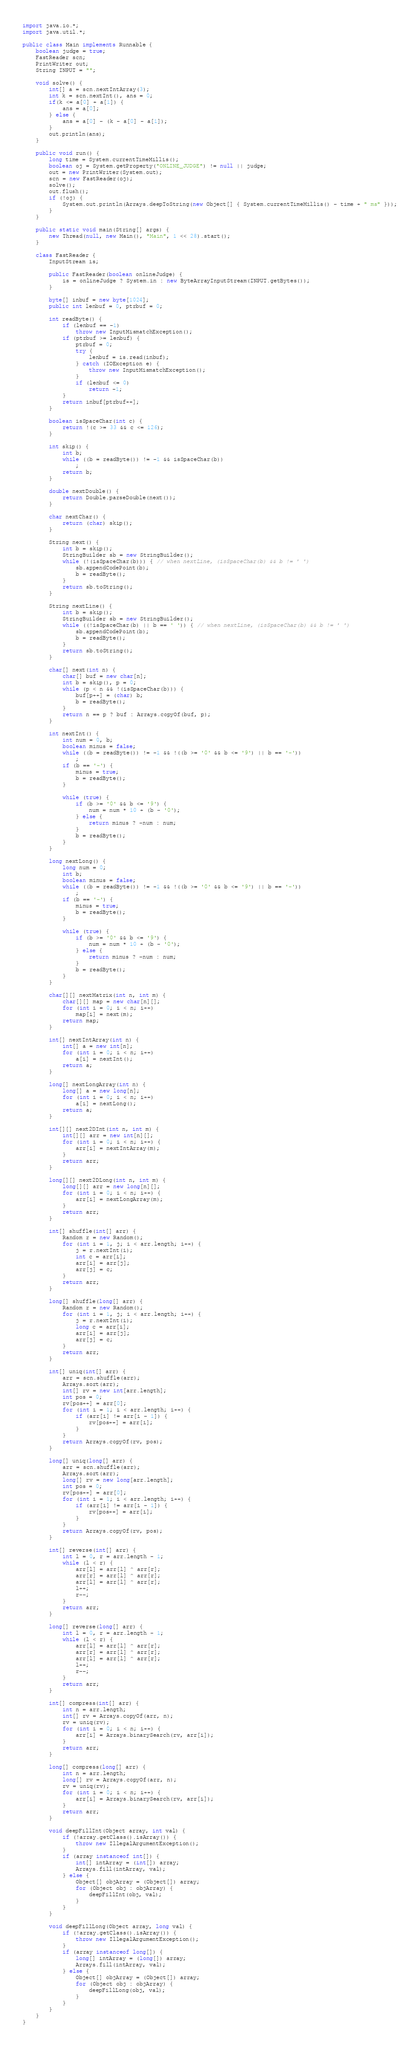<code> <loc_0><loc_0><loc_500><loc_500><_Java_>import java.io.*;
import java.util.*;

public class Main implements Runnable {
	boolean judge = true;
	FastReader scn;
	PrintWriter out;
	String INPUT = "";

	void solve() {
		int[] a = scn.nextIntArray(3);
		int k = scn.nextInt(), ans = 0;
		if(k <= a[0] + a[1]) {
			ans = a[0];
		} else {
			ans = a[0] - (k - a[0] - a[1]);
		}
		out.println(ans);
	}

	public void run() {
		long time = System.currentTimeMillis();
		boolean oj = System.getProperty("ONLINE_JUDGE") != null || judge;
		out = new PrintWriter(System.out);
		scn = new FastReader(oj);
		solve();
		out.flush();
		if (!oj) {
			System.out.println(Arrays.deepToString(new Object[] { System.currentTimeMillis() - time + " ms" }));
		}
	}

	public static void main(String[] args) {
		new Thread(null, new Main(), "Main", 1 << 28).start();
	}

	class FastReader {
		InputStream is;

		public FastReader(boolean onlineJudge) {
			is = onlineJudge ? System.in : new ByteArrayInputStream(INPUT.getBytes());
		}

		byte[] inbuf = new byte[1024];
		public int lenbuf = 0, ptrbuf = 0;

		int readByte() {
			if (lenbuf == -1)
				throw new InputMismatchException();
			if (ptrbuf >= lenbuf) {
				ptrbuf = 0;
				try {
					lenbuf = is.read(inbuf);
				} catch (IOException e) {
					throw new InputMismatchException();
				}
				if (lenbuf <= 0)
					return -1;
			}
			return inbuf[ptrbuf++];
		}

		boolean isSpaceChar(int c) {
			return !(c >= 33 && c <= 126);
		}

		int skip() {
			int b;
			while ((b = readByte()) != -1 && isSpaceChar(b))
				;
			return b;
		}

		double nextDouble() {
			return Double.parseDouble(next());
		}

		char nextChar() {
			return (char) skip();
		}

		String next() {
			int b = skip();
			StringBuilder sb = new StringBuilder();
			while (!(isSpaceChar(b))) { // when nextLine, (isSpaceChar(b) && b != ' ')
				sb.appendCodePoint(b);
				b = readByte();
			}
			return sb.toString();
		}

		String nextLine() {
			int b = skip();
			StringBuilder sb = new StringBuilder();
			while ((!isSpaceChar(b) || b == ' ')) { // when nextLine, (isSpaceChar(b) && b != ' ')
				sb.appendCodePoint(b);
				b = readByte();
			}
			return sb.toString();
		}

		char[] next(int n) {
			char[] buf = new char[n];
			int b = skip(), p = 0;
			while (p < n && !(isSpaceChar(b))) {
				buf[p++] = (char) b;
				b = readByte();
			}
			return n == p ? buf : Arrays.copyOf(buf, p);
		}

		int nextInt() {
			int num = 0, b;
			boolean minus = false;
			while ((b = readByte()) != -1 && !((b >= '0' && b <= '9') || b == '-'))
				;
			if (b == '-') {
				minus = true;
				b = readByte();
			}

			while (true) {
				if (b >= '0' && b <= '9') {
					num = num * 10 + (b - '0');
				} else {
					return minus ? -num : num;
				}
				b = readByte();
			}
		}

		long nextLong() {
			long num = 0;
			int b;
			boolean minus = false;
			while ((b = readByte()) != -1 && !((b >= '0' && b <= '9') || b == '-'))
				;
			if (b == '-') {
				minus = true;
				b = readByte();
			}

			while (true) {
				if (b >= '0' && b <= '9') {
					num = num * 10 + (b - '0');
				} else {
					return minus ? -num : num;
				}
				b = readByte();
			}
		}

		char[][] nextMatrix(int n, int m) {
			char[][] map = new char[n][];
			for (int i = 0; i < n; i++)
				map[i] = next(m);
			return map;
		}

		int[] nextIntArray(int n) {
			int[] a = new int[n];
			for (int i = 0; i < n; i++)
				a[i] = nextInt();
			return a;
		}

		long[] nextLongArray(int n) {
			long[] a = new long[n];
			for (int i = 0; i < n; i++)
				a[i] = nextLong();
			return a;
		}

		int[][] next2DInt(int n, int m) {
			int[][] arr = new int[n][];
			for (int i = 0; i < n; i++) {
				arr[i] = nextIntArray(m);
			}
			return arr;
		}

		long[][] next2DLong(int n, int m) {
			long[][] arr = new long[n][];
			for (int i = 0; i < n; i++) {
				arr[i] = nextLongArray(m);
			}
			return arr;
		}

		int[] shuffle(int[] arr) {
			Random r = new Random();
			for (int i = 1, j; i < arr.length; i++) {
				j = r.nextInt(i);
				int c = arr[i];
				arr[i] = arr[j];
				arr[j] = c;
			}
			return arr;
		}

		long[] shuffle(long[] arr) {
			Random r = new Random();
			for (int i = 1, j; i < arr.length; i++) {
				j = r.nextInt(i);
				long c = arr[i];
				arr[i] = arr[j];
				arr[j] = c;
			}
			return arr;
		}

		int[] uniq(int[] arr) {
			arr = scn.shuffle(arr);
			Arrays.sort(arr);
			int[] rv = new int[arr.length];
			int pos = 0;
			rv[pos++] = arr[0];
			for (int i = 1; i < arr.length; i++) {
				if (arr[i] != arr[i - 1]) {
					rv[pos++] = arr[i];
				}
			}
			return Arrays.copyOf(rv, pos);
		}

		long[] uniq(long[] arr) {
			arr = scn.shuffle(arr);
			Arrays.sort(arr);
			long[] rv = new long[arr.length];
			int pos = 0;
			rv[pos++] = arr[0];
			for (int i = 1; i < arr.length; i++) {
				if (arr[i] != arr[i - 1]) {
					rv[pos++] = arr[i];
				}
			}
			return Arrays.copyOf(rv, pos);
		}

		int[] reverse(int[] arr) {
			int l = 0, r = arr.length - 1;
			while (l < r) {
				arr[l] = arr[l] ^ arr[r];
				arr[r] = arr[l] ^ arr[r];
				arr[l] = arr[l] ^ arr[r];
				l++;
				r--;
			}
			return arr;
		}

		long[] reverse(long[] arr) {
			int l = 0, r = arr.length - 1;
			while (l < r) {
				arr[l] = arr[l] ^ arr[r];
				arr[r] = arr[l] ^ arr[r];
				arr[l] = arr[l] ^ arr[r];
				l++;
				r--;
			}
			return arr;
		}

		int[] compress(int[] arr) {
			int n = arr.length;
			int[] rv = Arrays.copyOf(arr, n);
			rv = uniq(rv);
			for (int i = 0; i < n; i++) {
				arr[i] = Arrays.binarySearch(rv, arr[i]);
			}
			return arr;
		}

		long[] compress(long[] arr) {
			int n = arr.length;
			long[] rv = Arrays.copyOf(arr, n);
			rv = uniq(rv);
			for (int i = 0; i < n; i++) {
				arr[i] = Arrays.binarySearch(rv, arr[i]);
			}
			return arr;
		}

		void deepFillInt(Object array, int val) {
			if (!array.getClass().isArray()) {
				throw new IllegalArgumentException();
			}
			if (array instanceof int[]) {
				int[] intArray = (int[]) array;
				Arrays.fill(intArray, val);
			} else {
				Object[] objArray = (Object[]) array;
				for (Object obj : objArray) {
					deepFillInt(obj, val);
				}
			}
		}

		void deepFillLong(Object array, long val) {
			if (!array.getClass().isArray()) {
				throw new IllegalArgumentException();
			}
			if (array instanceof long[]) {
				long[] intArray = (long[]) array;
				Arrays.fill(intArray, val);
			} else {
				Object[] objArray = (Object[]) array;
				for (Object obj : objArray) {
					deepFillLong(obj, val);
				}
			}
		}
	}
}</code> 